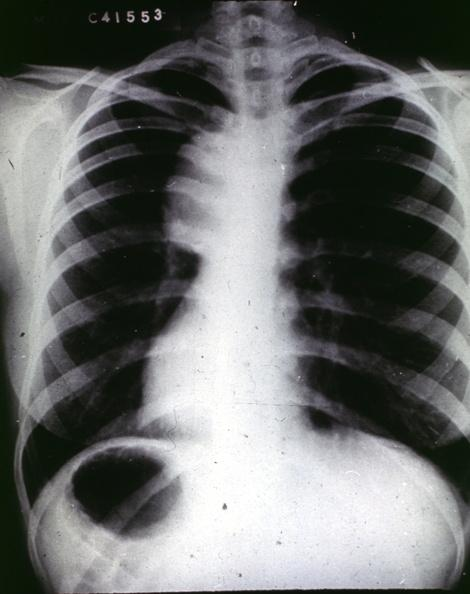s acute peritonitis present?
Answer the question using a single word or phrase. No 